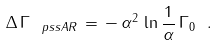<formula> <loc_0><loc_0><loc_500><loc_500>\Delta \, \Gamma _ { \ p s s A R } \, = \, - \, \alpha ^ { 2 } \, \ln \frac { 1 } { \alpha } \, \Gamma _ { 0 } \ .</formula> 